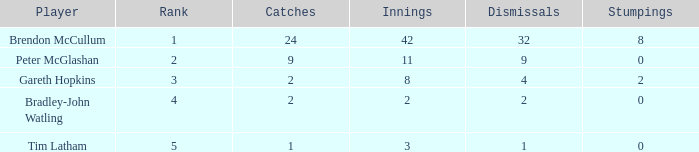List the ranks of all dismissals with a value of 4 3.0. Parse the full table. {'header': ['Player', 'Rank', 'Catches', 'Innings', 'Dismissals', 'Stumpings'], 'rows': [['Brendon McCullum', '1', '24', '42', '32', '8'], ['Peter McGlashan', '2', '9', '11', '9', '0'], ['Gareth Hopkins', '3', '2', '8', '4', '2'], ['Bradley-John Watling', '4', '2', '2', '2', '0'], ['Tim Latham', '5', '1', '3', '1', '0']]} 